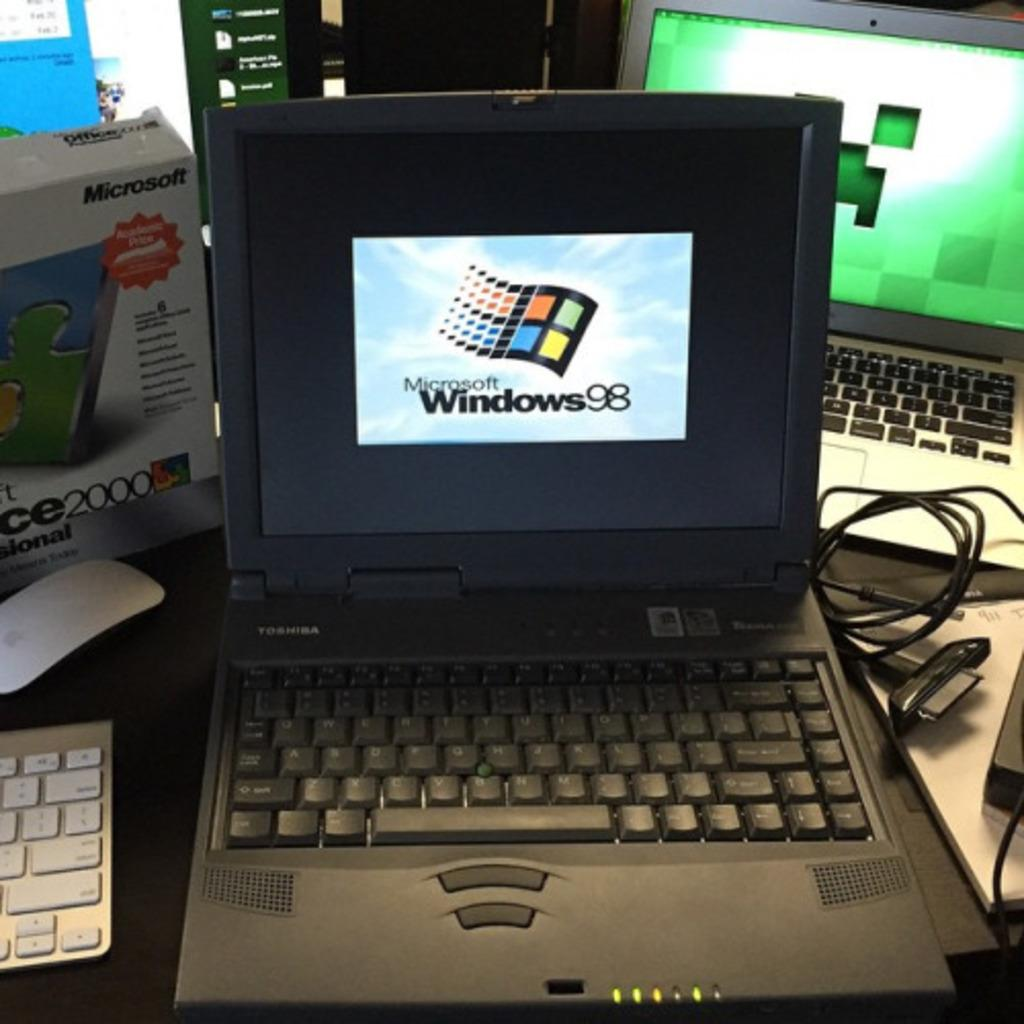<image>
Render a clear and concise summary of the photo. Two laptops back to front with one showing the windows 98 logo and the other a picture of a creeper from minecraft. 